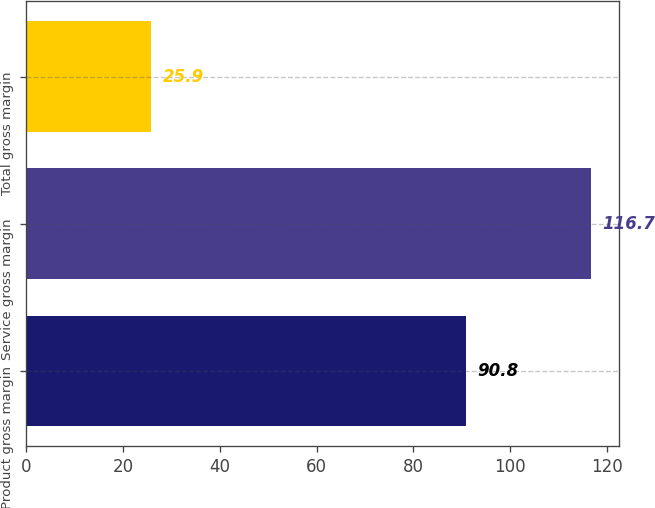Convert chart to OTSL. <chart><loc_0><loc_0><loc_500><loc_500><bar_chart><fcel>Product gross margin<fcel>Service gross margin<fcel>Total gross margin<nl><fcel>90.8<fcel>116.7<fcel>25.9<nl></chart> 